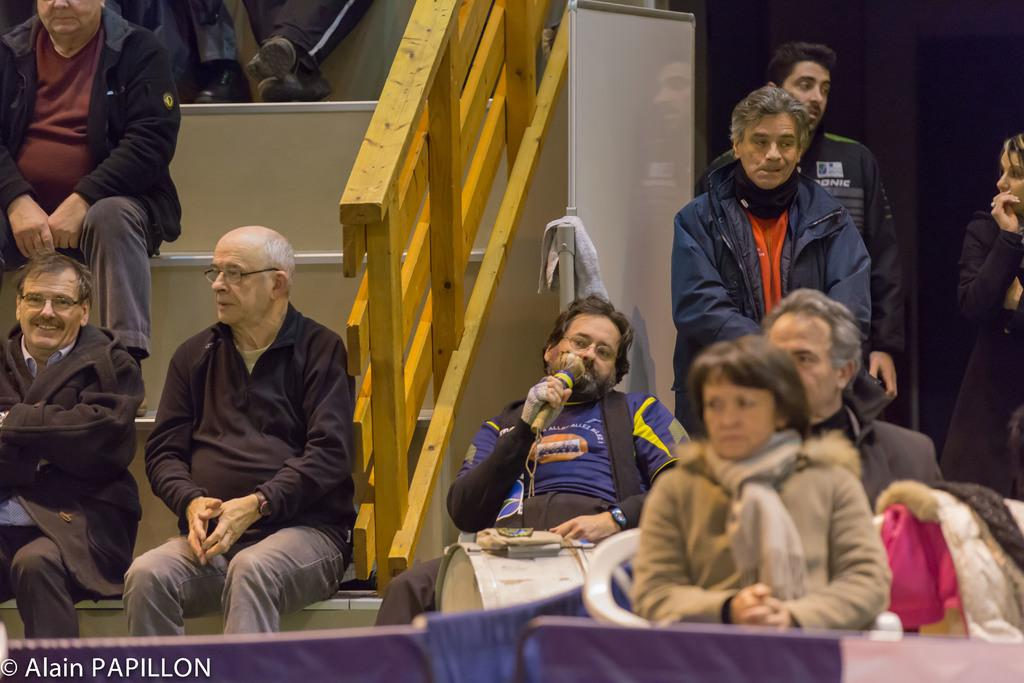What are the people in the image doing? The people in the image are sitting and standing. What can be seen at the bottom of the image? There is fencing at the bottom of the image. How does the wind affect the people in the image? There is no indication of wind in the image, so its effect on the people cannot be determined. 